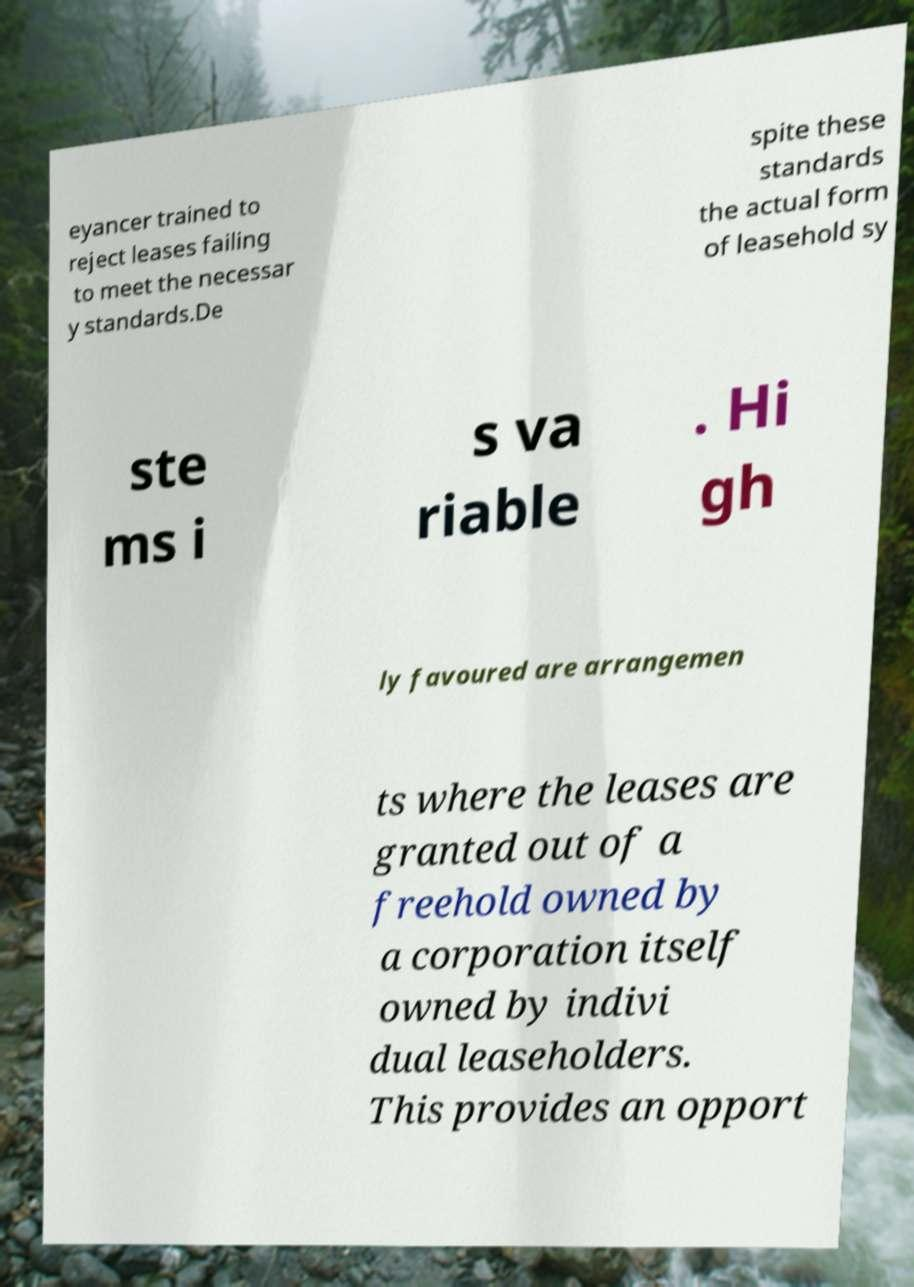Could you assist in decoding the text presented in this image and type it out clearly? eyancer trained to reject leases failing to meet the necessar y standards.De spite these standards the actual form of leasehold sy ste ms i s va riable . Hi gh ly favoured are arrangemen ts where the leases are granted out of a freehold owned by a corporation itself owned by indivi dual leaseholders. This provides an opport 